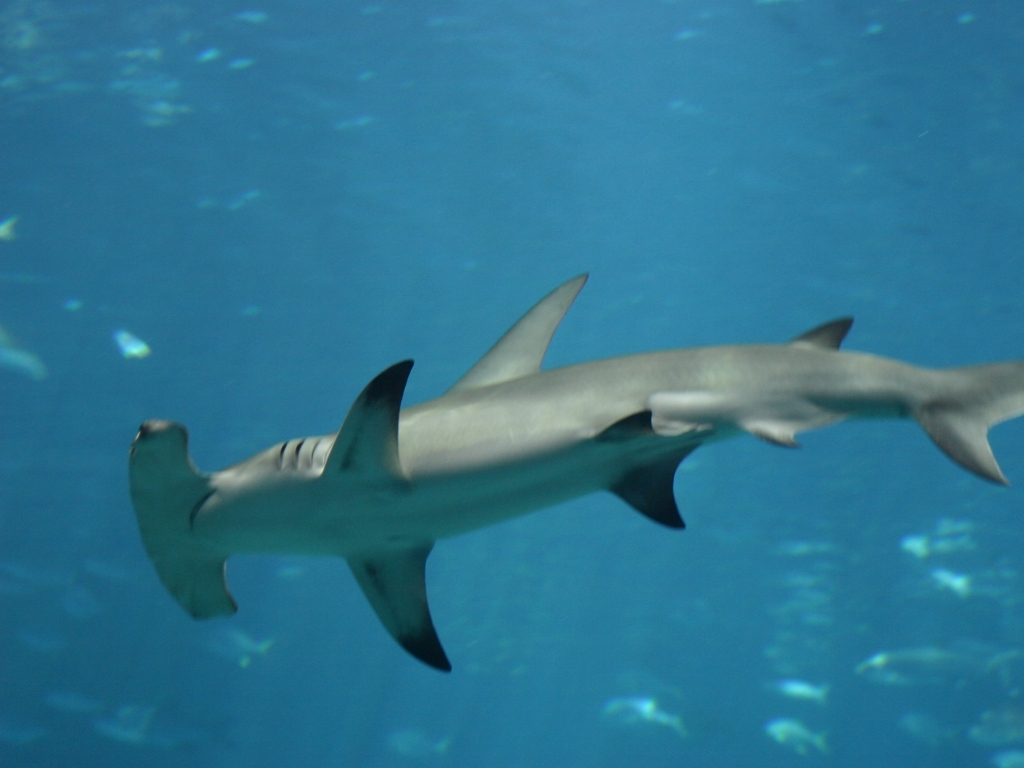How clear are the details?
A. Clear
B. Extremely blurry
C. Somewhat blurry
Answer with the option's letter from the given choices directly. The visibility of details in the image is moderate—it's not extremely sharp, but it's definitely not extremely blurry either. The main subject, which appears to be a hammerhead shark, is discernible with key features like the eyes and fins visible. Therefore, the most accurate answer would be C. Somewhat blurry, as the finer textures and smaller elements in the background aren't as clear as they could be. 